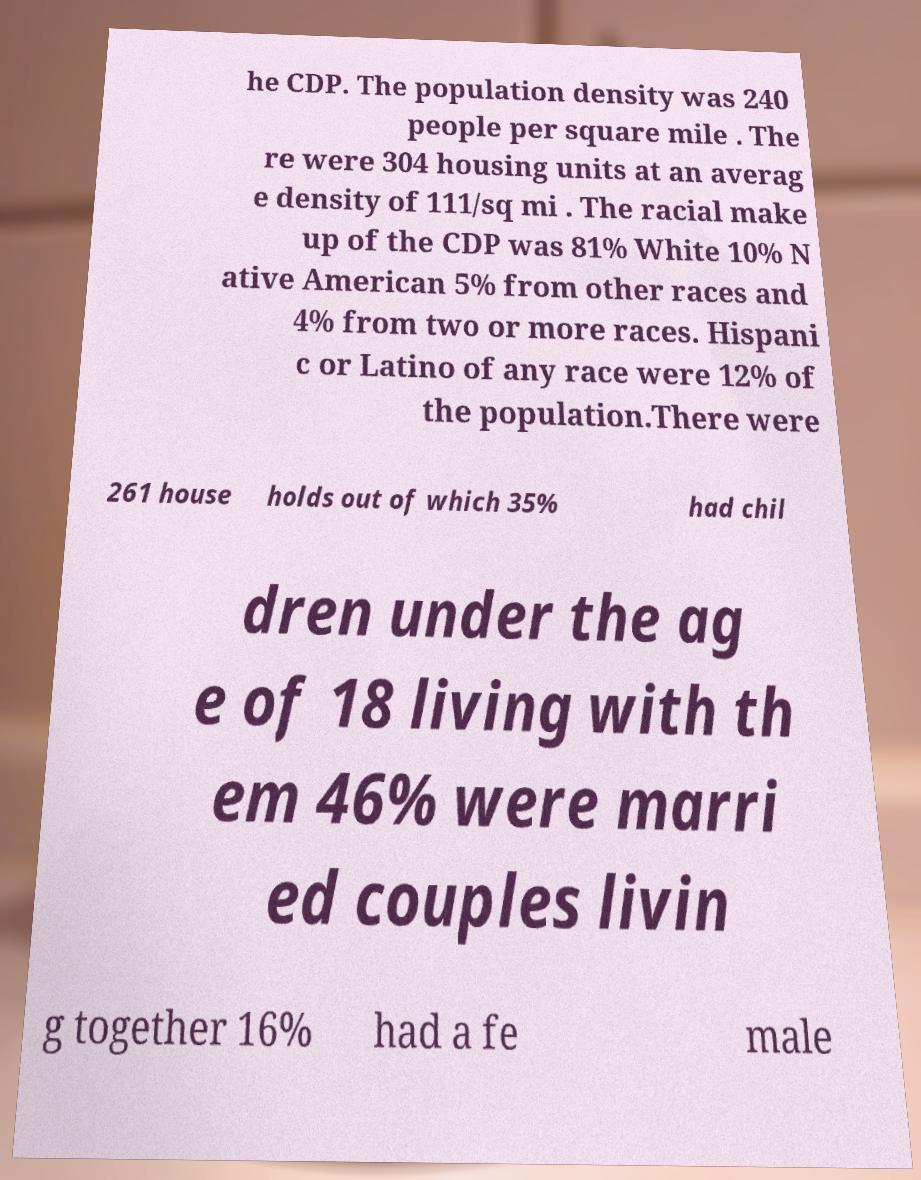What messages or text are displayed in this image? I need them in a readable, typed format. he CDP. The population density was 240 people per square mile . The re were 304 housing units at an averag e density of 111/sq mi . The racial make up of the CDP was 81% White 10% N ative American 5% from other races and 4% from two or more races. Hispani c or Latino of any race were 12% of the population.There were 261 house holds out of which 35% had chil dren under the ag e of 18 living with th em 46% were marri ed couples livin g together 16% had a fe male 